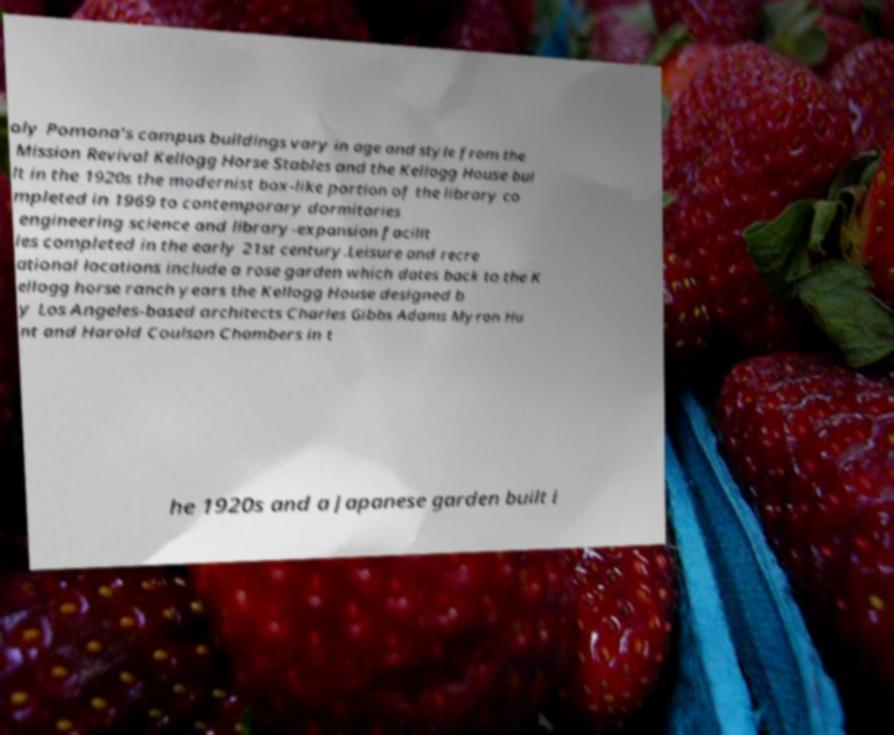Can you accurately transcribe the text from the provided image for me? oly Pomona's campus buildings vary in age and style from the Mission Revival Kellogg Horse Stables and the Kellogg House bui lt in the 1920s the modernist box-like portion of the library co mpleted in 1969 to contemporary dormitories engineering science and library-expansion facilit ies completed in the early 21st century.Leisure and recre ational locations include a rose garden which dates back to the K ellogg horse ranch years the Kellogg House designed b y Los Angeles-based architects Charles Gibbs Adams Myron Hu nt and Harold Coulson Chambers in t he 1920s and a Japanese garden built i 